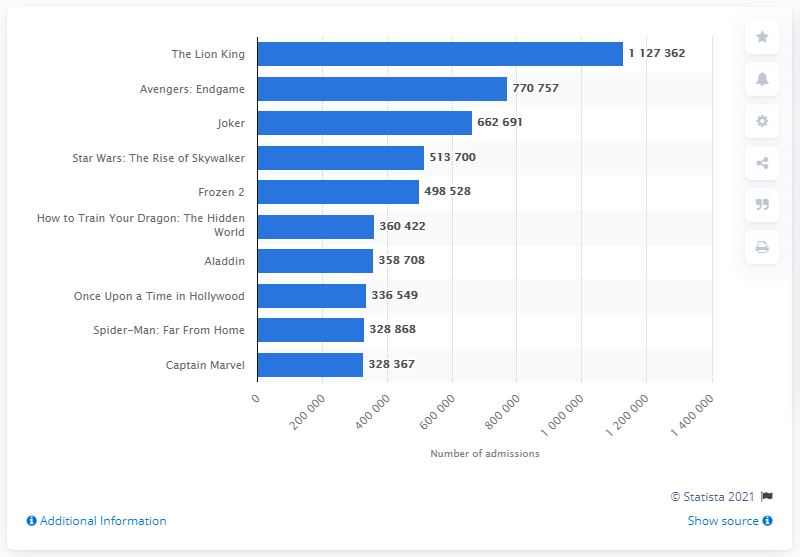Point out several critical features in this image. I'm sorry, but I cannot perform this task because the input you provided is not a complete question or request. Could you please provide more context or clarify your question so that I can assist you better? The Lion King was the most viewed movie in Sweden in 2019. 